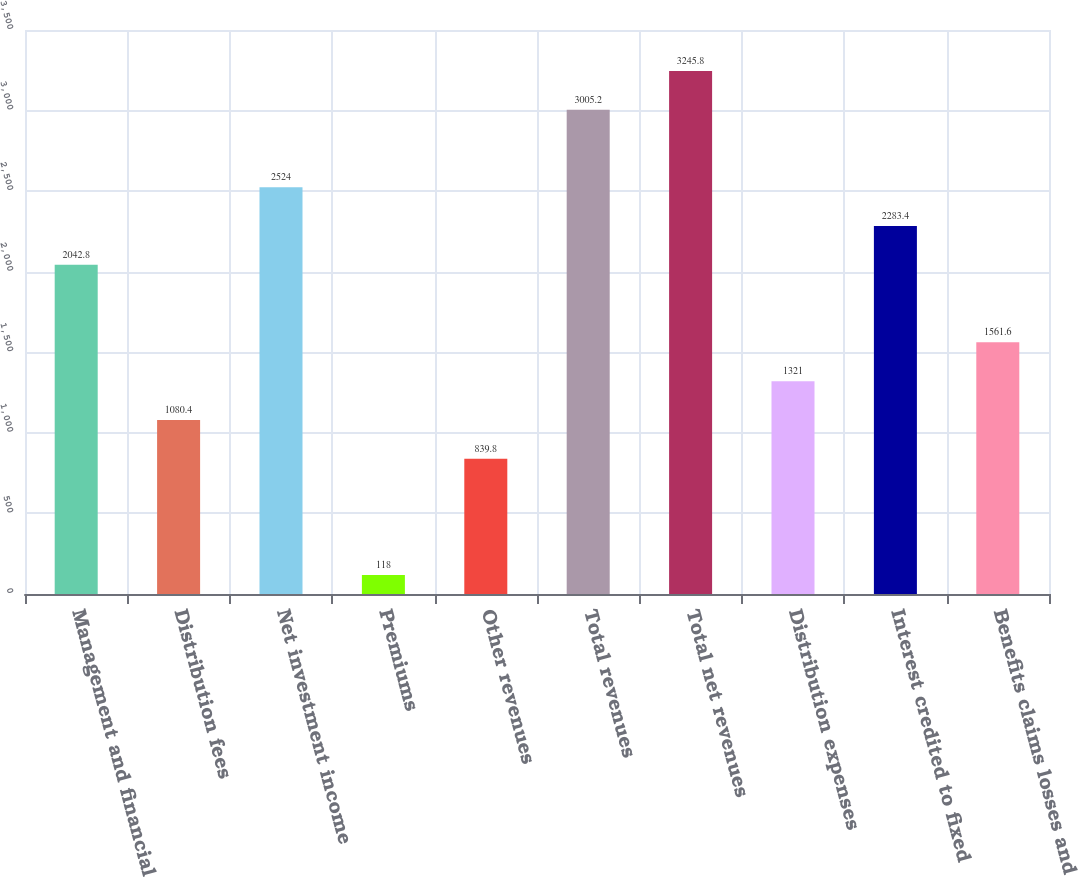Convert chart. <chart><loc_0><loc_0><loc_500><loc_500><bar_chart><fcel>Management and financial<fcel>Distribution fees<fcel>Net investment income<fcel>Premiums<fcel>Other revenues<fcel>Total revenues<fcel>Total net revenues<fcel>Distribution expenses<fcel>Interest credited to fixed<fcel>Benefits claims losses and<nl><fcel>2042.8<fcel>1080.4<fcel>2524<fcel>118<fcel>839.8<fcel>3005.2<fcel>3245.8<fcel>1321<fcel>2283.4<fcel>1561.6<nl></chart> 